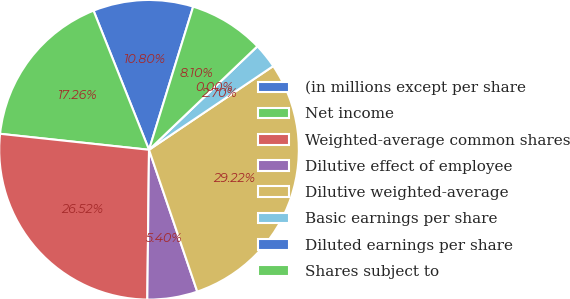Convert chart. <chart><loc_0><loc_0><loc_500><loc_500><pie_chart><fcel>(in millions except per share<fcel>Net income<fcel>Weighted-average common shares<fcel>Dilutive effect of employee<fcel>Dilutive weighted-average<fcel>Basic earnings per share<fcel>Diluted earnings per share<fcel>Shares subject to<nl><fcel>10.8%<fcel>17.26%<fcel>26.52%<fcel>5.4%<fcel>29.22%<fcel>2.7%<fcel>0.0%<fcel>8.1%<nl></chart> 